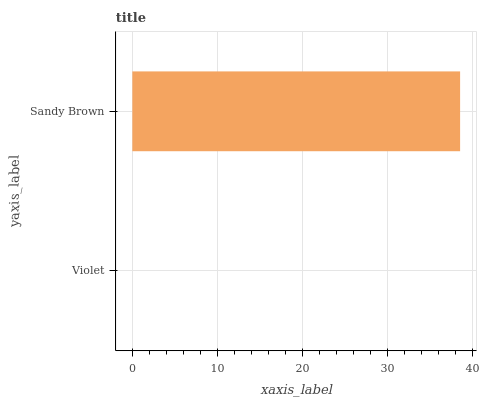Is Violet the minimum?
Answer yes or no. Yes. Is Sandy Brown the maximum?
Answer yes or no. Yes. Is Sandy Brown the minimum?
Answer yes or no. No. Is Sandy Brown greater than Violet?
Answer yes or no. Yes. Is Violet less than Sandy Brown?
Answer yes or no. Yes. Is Violet greater than Sandy Brown?
Answer yes or no. No. Is Sandy Brown less than Violet?
Answer yes or no. No. Is Sandy Brown the high median?
Answer yes or no. Yes. Is Violet the low median?
Answer yes or no. Yes. Is Violet the high median?
Answer yes or no. No. Is Sandy Brown the low median?
Answer yes or no. No. 